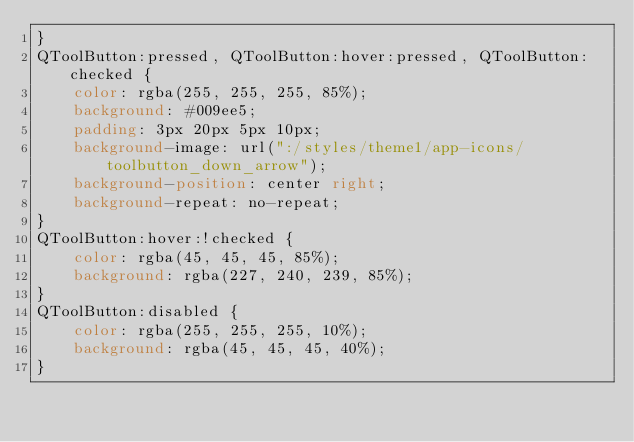<code> <loc_0><loc_0><loc_500><loc_500><_CSS_>}
QToolButton:pressed, QToolButton:hover:pressed, QToolButton:checked {
    color: rgba(255, 255, 255, 85%);
    background: #009ee5;
    padding: 3px 20px 5px 10px;
    background-image: url(":/styles/theme1/app-icons/toolbutton_down_arrow");
    background-position: center right;
    background-repeat: no-repeat;
}
QToolButton:hover:!checked {
    color: rgba(45, 45, 45, 85%);
    background: rgba(227, 240, 239, 85%);
}
QToolButton:disabled {
    color: rgba(255, 255, 255, 10%);
    background: rgba(45, 45, 45, 40%);
}
</code> 